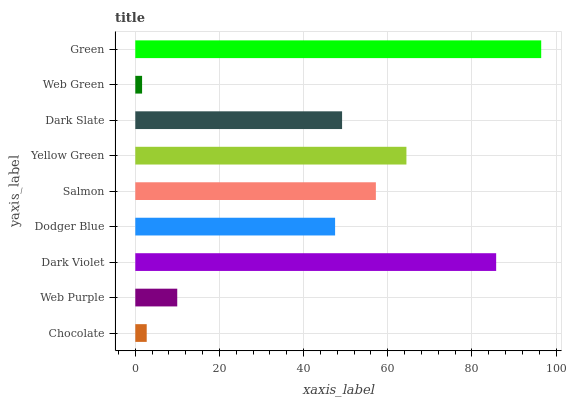Is Web Green the minimum?
Answer yes or no. Yes. Is Green the maximum?
Answer yes or no. Yes. Is Web Purple the minimum?
Answer yes or no. No. Is Web Purple the maximum?
Answer yes or no. No. Is Web Purple greater than Chocolate?
Answer yes or no. Yes. Is Chocolate less than Web Purple?
Answer yes or no. Yes. Is Chocolate greater than Web Purple?
Answer yes or no. No. Is Web Purple less than Chocolate?
Answer yes or no. No. Is Dark Slate the high median?
Answer yes or no. Yes. Is Dark Slate the low median?
Answer yes or no. Yes. Is Yellow Green the high median?
Answer yes or no. No. Is Chocolate the low median?
Answer yes or no. No. 